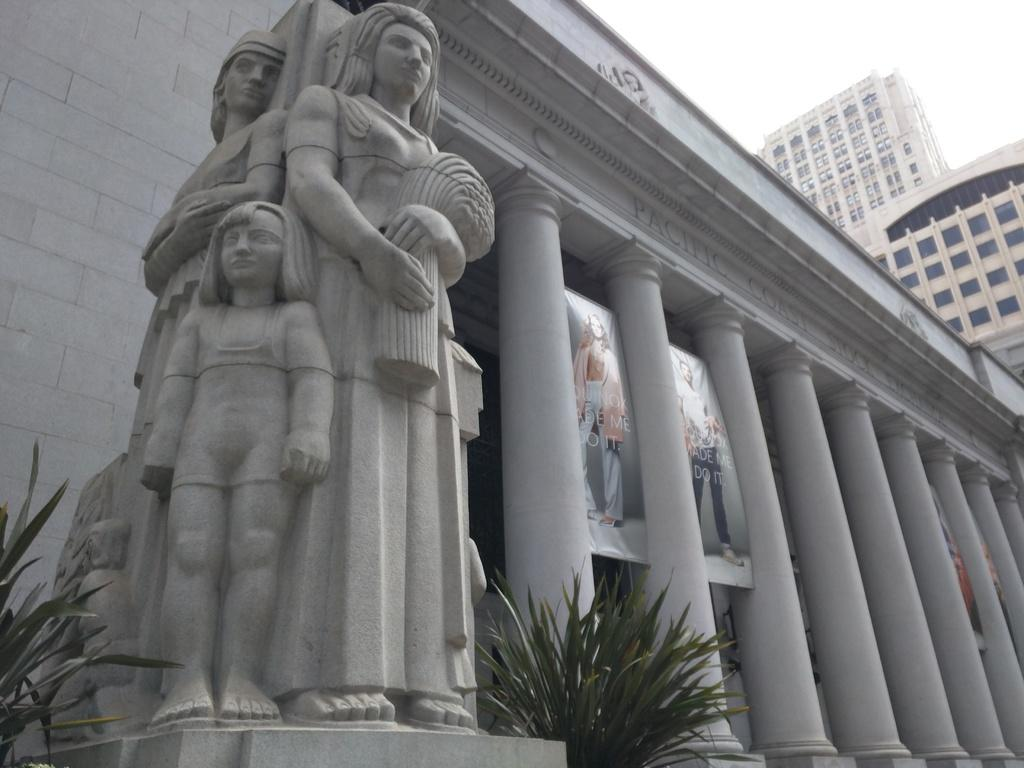What can be seen in the image that represents people? There are statues of two people and a child in the image. What architectural features are present in the image? There are pillars in the image. What type of natural elements can be seen in the image? There are plants in the image. What type of structures are visible in the image? There are buildings in the image. What part of the buildings can be seen in the image? There are windows of the building in the image. What additional object is present in the image? There is a banner in the image. What is the color of the sky in the image? The sky is white in the image. Can you hear the grandfather whistling in the image? There is no grandfather or whistling present in the image; it only features statues, pillars, plants, buildings, windows, and a banner. 